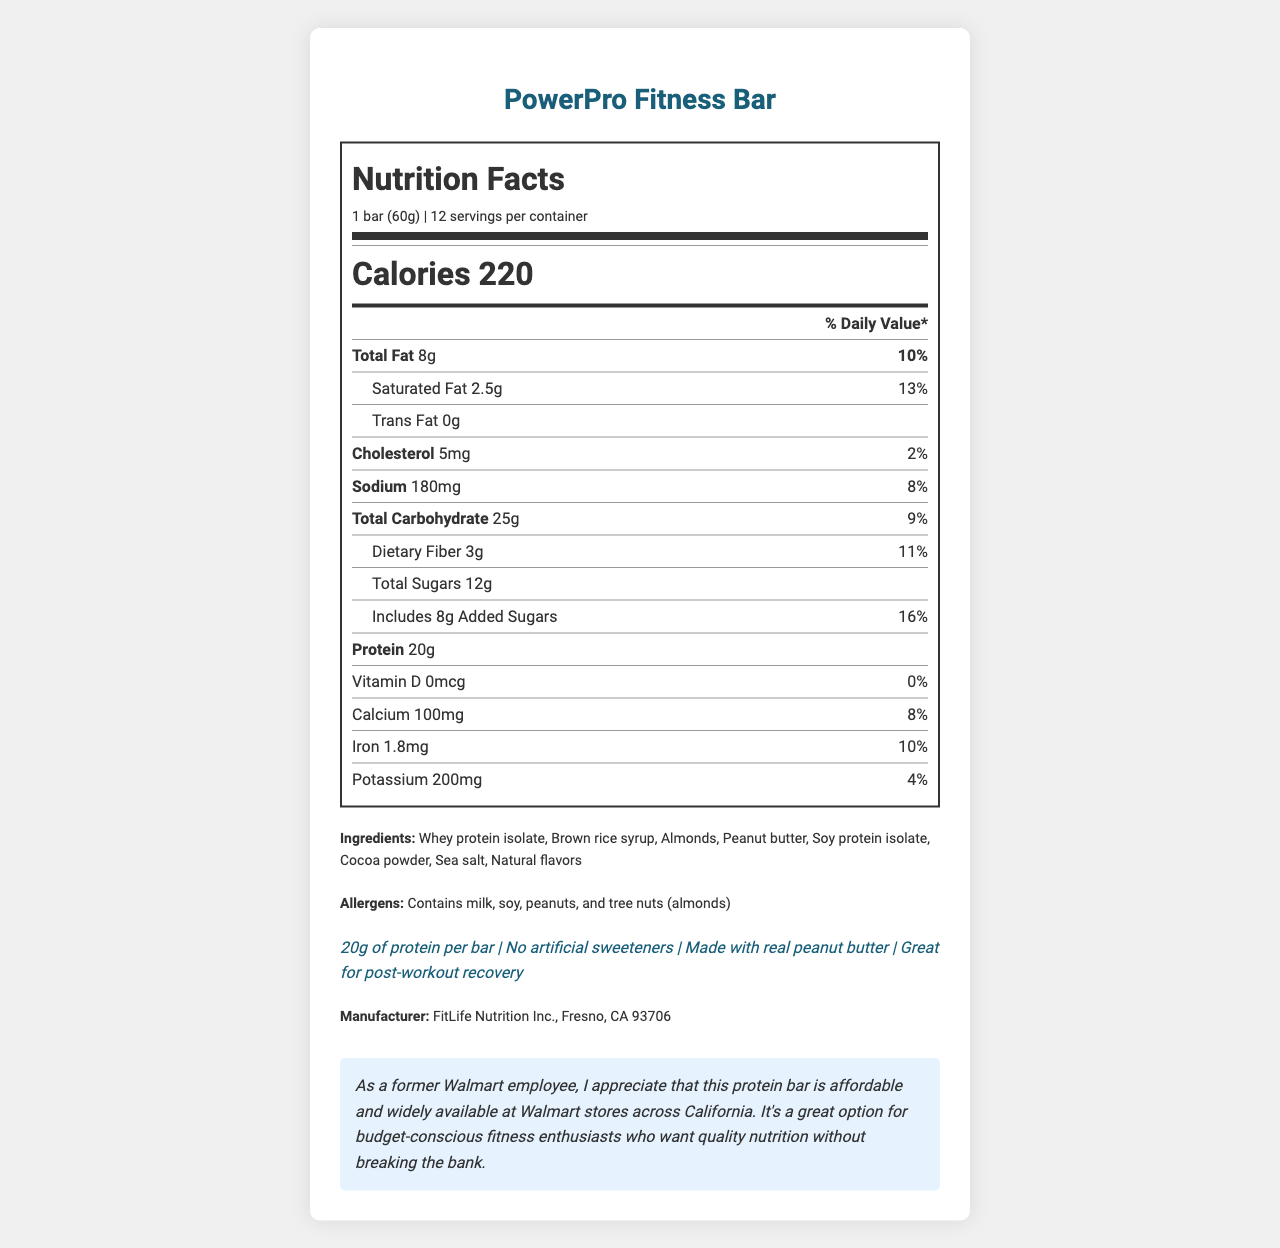what is the serving size? The document states that the serving size is one bar (60g).
Answer: 1 bar (60g) how many servings are in the container? The document specifies that there are 12 servings per container.
Answer: 12 how many calories are in one serving? The document lists the calorie content as 220 calories per bar.
Answer: 220 what is the total fat content per serving? The document states that the total fat content is 8 grams per bar.
Answer: 8g what percentage of the daily value of sodium does one bar contain? The document indicates that a serving contains 180mg of sodium, which is 8% of the daily value.
Answer: 8% which nutrient has the highest daily value percentage? A. Protein B. Added Sugars C. Saturated Fat D. Vitamin D Added sugars have the highest daily value percentage at 16%.
Answer: B how much protein does one bar contain? A. 10g B. 15g C. 20g D. 25g One bar contains 20 grams of protein.
Answer: C is there any cholesterol in the protein bar? The document shows that the bar contains 5mg of cholesterol.
Answer: Yes does the protein bar contain any trans fat? The document indicates that the bar has 0 grams of trans fat.
Answer: No what ingredients should people with peanut allergies avoid in this product? The document lists peanuts as an allergen, specifically mentioning peanut butter.
Answer: Peanut butter, peanuts summarize the key nutritional aspects of the protein bar. The document details the nutritional profile, including calories, protein, fats, carbs, and key vitamins and minerals, tailored for fitness enthusiasts.
Answer: The PowerPro Fitness Bar provides 220 calories per bar with 20g of protein, 8g of total fat, and 25g of carbohydrates. It has important nutrients like fiber (3g) and iron (1.8mg). The bar contains a blend of whey and soy protein isolates, and it’s designed for fitness enthusiasts, marketed as ideal for post-workout recovery. what is the iron content in one bar? The document states that the iron content is 1.8mg per bar.
Answer: 1.8mg what are some of the marketing claims made about the protein bar? The document lists these claims in the claims section.
Answer: 20g of protein per bar, No artificial sweeteners, Made with real peanut butter, Great for post-workout recovery how much added sugar is in one bar? The document specifies that one bar includes 8 grams of added sugar.
Answer: 8g are any artificial sweeteners used in the PowerPro Fitness Bar? The document claims that the bar contains no artificial sweeteners.
Answer: No what is the manufacturer of the protein bar and where is it located? The document indicates the manufacturer and its location.
Answer: FitLife Nutrition Inc., Fresno, CA 93706 what is the daily value percentage of calcium in one serving? The document shows that one serving contains 100mg of calcium, which is 8% of the daily value.
Answer: 8% which allergen is NOT present in the protein bar? A. Soy B. Peanuts C. Gluten D. Milk The document lists milk, soy, peanuts, and tree nuts (almonds) as allergens, but not gluten.
Answer: C 